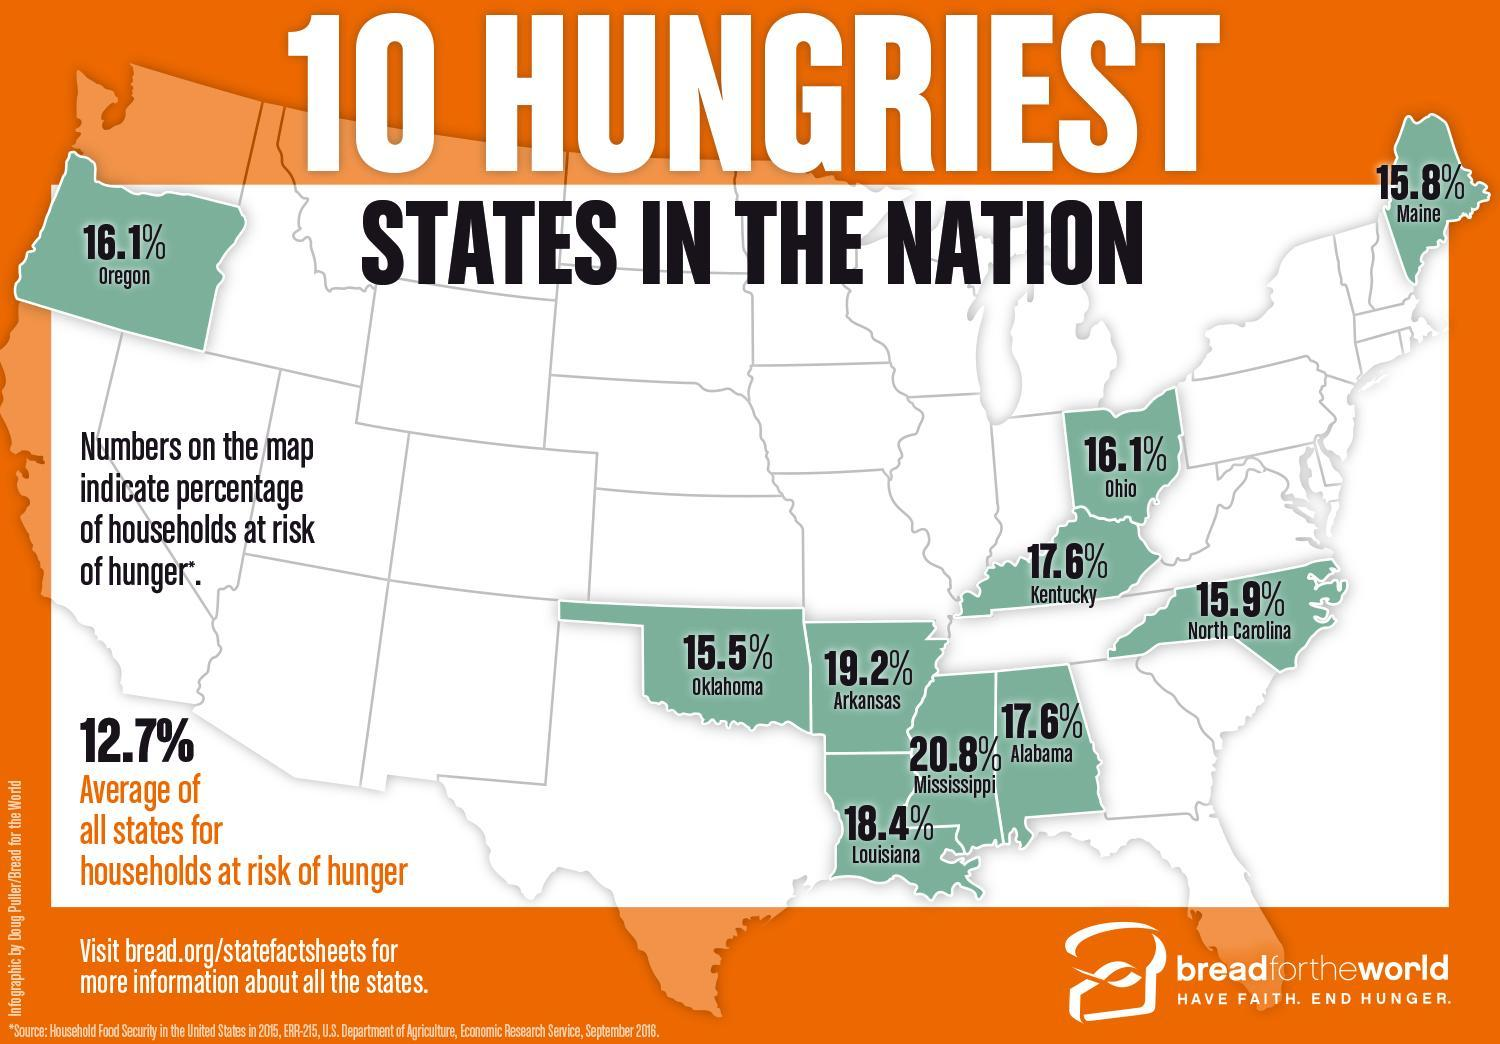Compared to Ohio, how much higher in percentage is the households at risk of hunger in Kentucky?
Answer the question with a short phrase. 1.5% Which state has the second highest percentage of households at risk of hunger? arkansas What is the total percentage of households at risk of hunger in Oklahoma and Arkansas? 34.7 